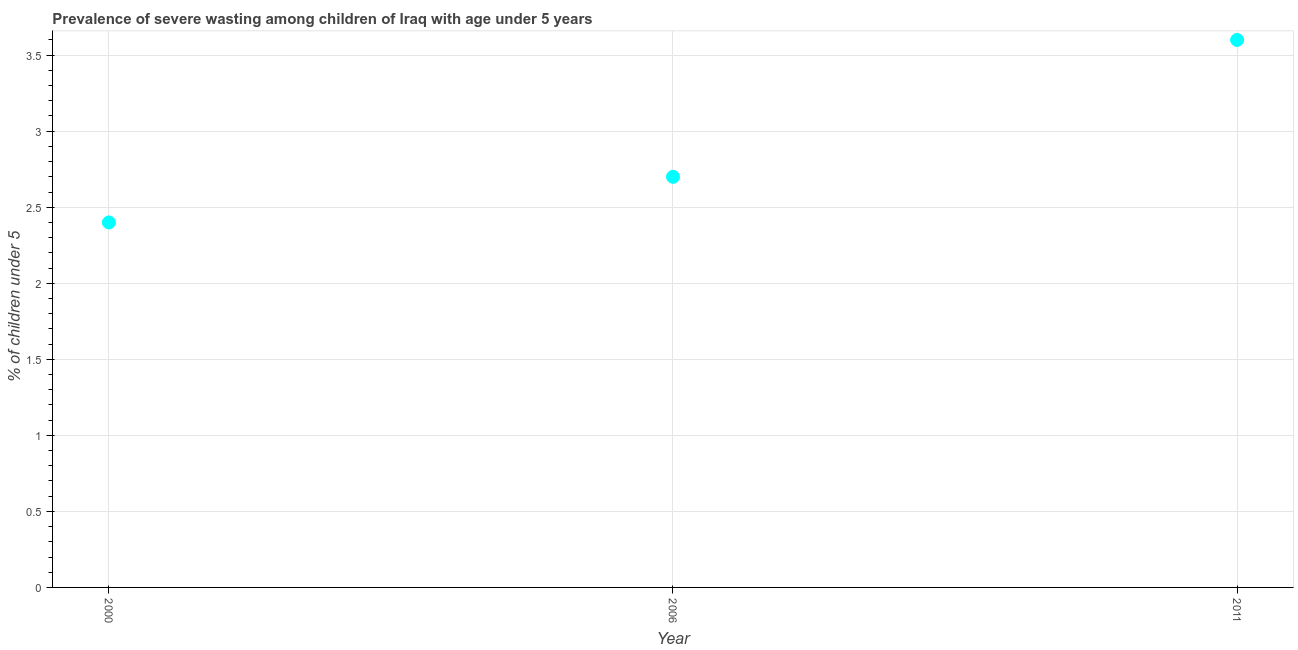What is the prevalence of severe wasting in 2000?
Ensure brevity in your answer.  2.4. Across all years, what is the maximum prevalence of severe wasting?
Your answer should be very brief. 3.6. Across all years, what is the minimum prevalence of severe wasting?
Provide a short and direct response. 2.4. In which year was the prevalence of severe wasting maximum?
Keep it short and to the point. 2011. In which year was the prevalence of severe wasting minimum?
Offer a terse response. 2000. What is the sum of the prevalence of severe wasting?
Offer a terse response. 8.7. What is the difference between the prevalence of severe wasting in 2006 and 2011?
Your answer should be very brief. -0.9. What is the average prevalence of severe wasting per year?
Offer a terse response. 2.9. What is the median prevalence of severe wasting?
Keep it short and to the point. 2.7. In how many years, is the prevalence of severe wasting greater than 0.4 %?
Your answer should be very brief. 3. Do a majority of the years between 2006 and 2011 (inclusive) have prevalence of severe wasting greater than 1 %?
Your response must be concise. Yes. What is the ratio of the prevalence of severe wasting in 2000 to that in 2006?
Offer a very short reply. 0.89. Is the prevalence of severe wasting in 2000 less than that in 2011?
Your answer should be very brief. Yes. Is the difference between the prevalence of severe wasting in 2000 and 2011 greater than the difference between any two years?
Your response must be concise. Yes. What is the difference between the highest and the second highest prevalence of severe wasting?
Provide a short and direct response. 0.9. What is the difference between the highest and the lowest prevalence of severe wasting?
Make the answer very short. 1.2. In how many years, is the prevalence of severe wasting greater than the average prevalence of severe wasting taken over all years?
Your response must be concise. 1. Does the prevalence of severe wasting monotonically increase over the years?
Make the answer very short. Yes. How many dotlines are there?
Your answer should be compact. 1. How many years are there in the graph?
Offer a very short reply. 3. Does the graph contain grids?
Your response must be concise. Yes. What is the title of the graph?
Provide a short and direct response. Prevalence of severe wasting among children of Iraq with age under 5 years. What is the label or title of the X-axis?
Your answer should be very brief. Year. What is the label or title of the Y-axis?
Your response must be concise.  % of children under 5. What is the  % of children under 5 in 2000?
Ensure brevity in your answer.  2.4. What is the  % of children under 5 in 2006?
Your answer should be compact. 2.7. What is the  % of children under 5 in 2011?
Your response must be concise. 3.6. What is the difference between the  % of children under 5 in 2000 and 2011?
Give a very brief answer. -1.2. What is the difference between the  % of children under 5 in 2006 and 2011?
Offer a terse response. -0.9. What is the ratio of the  % of children under 5 in 2000 to that in 2006?
Provide a short and direct response. 0.89. What is the ratio of the  % of children under 5 in 2000 to that in 2011?
Make the answer very short. 0.67. 